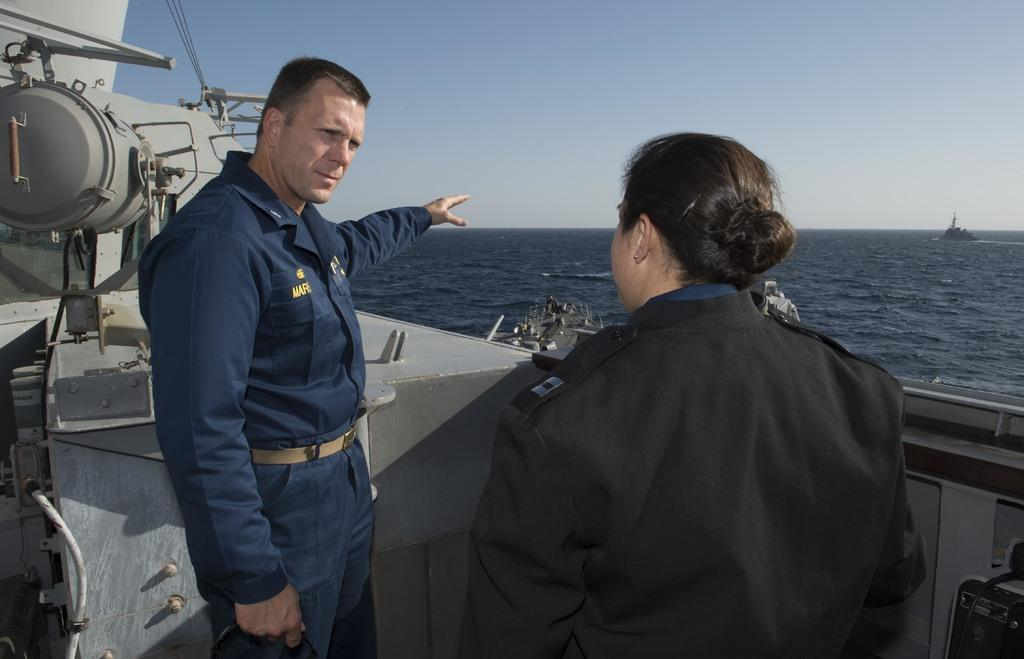How many people are present in the image? There are two people in the image, a woman and a man. What are the people in the image doing? Both the woman and the man are standing. What are they wearing? They are wearing uniforms. What can be seen in the background of the image? There is water and a boat visible in the background. What is located on the left side of the image? There are machines on the left side of the image. What type of cloth is the woman using to cover her elbow in the image? There is no cloth or mention of an elbow in the image; the woman is wearing a uniform and standing with the man. 